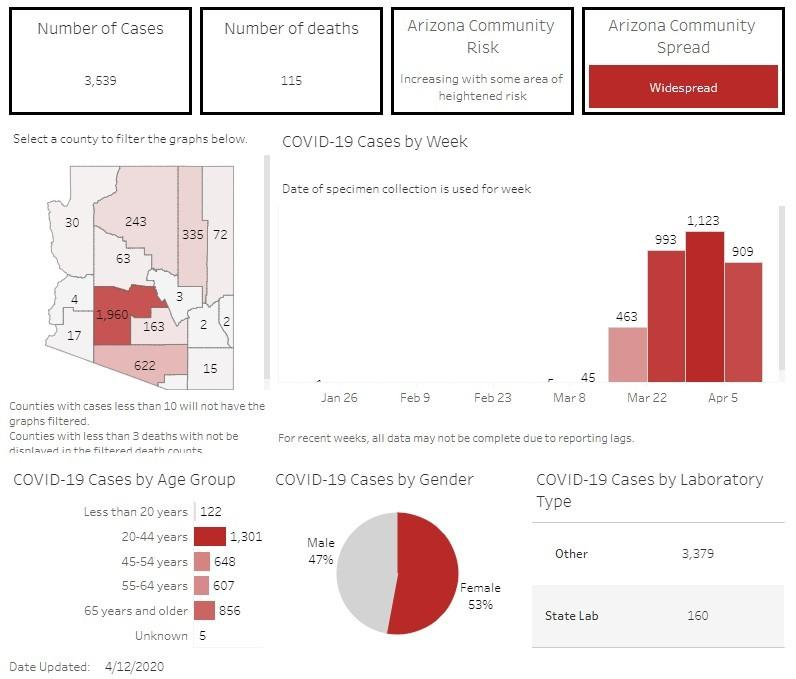List a handful of essential elements in this visual. As of April 12, 2020, the reported number of COVID-19 deaths in Arizona is 115. As of April 12, 2020, the state laboratory in Arizona had conducted 160 COVID-19 tests. As of April 12, 2020, the total number of reported positive cases of COVID-19 in Arizona was 3,539. As of April 12, 2020, it was reported that 53% of the COVID-19 patients in Arizona were females. As of 4/12/2020, there were a reported 1,301 cases of Covid-19 among individuals aged 20-44 years in the state of Arizona. 